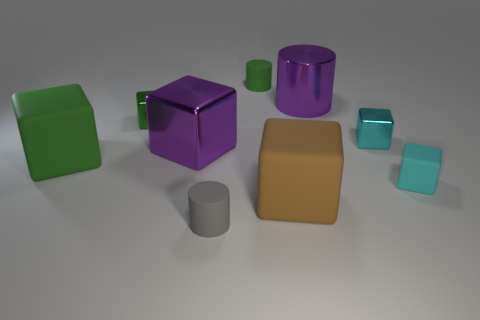There is a green cube that is behind the green object in front of the cyan block that is behind the purple shiny block; what is its material?
Provide a succinct answer. Metal. What number of other objects are there of the same size as the brown rubber cube?
Make the answer very short. 3. Do the large shiny cube and the small matte cube have the same color?
Give a very brief answer. No. How many small gray matte objects are in front of the tiny rubber object behind the green block that is in front of the green metal thing?
Your answer should be compact. 1. The tiny cylinder behind the cylinder that is in front of the tiny green metallic block is made of what material?
Make the answer very short. Rubber. Is there a cyan matte thing of the same shape as the green shiny object?
Provide a succinct answer. Yes. What is the color of the rubber object that is the same size as the green matte block?
Your response must be concise. Brown. What number of things are either shiny blocks that are in front of the tiny green shiny cube or matte things in front of the green metal block?
Provide a succinct answer. 6. What number of objects are either large rubber objects or purple cubes?
Provide a short and direct response. 3. How big is the matte thing that is behind the tiny gray cylinder and in front of the tiny cyan matte object?
Provide a short and direct response. Large. 